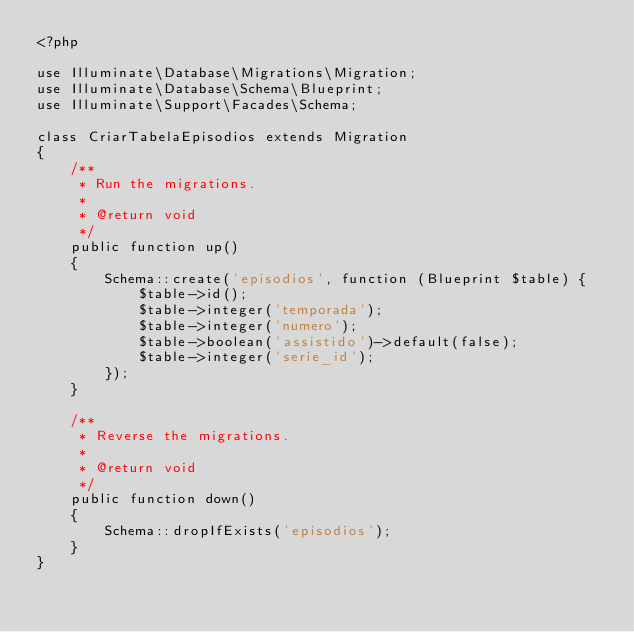Convert code to text. <code><loc_0><loc_0><loc_500><loc_500><_PHP_><?php

use Illuminate\Database\Migrations\Migration;
use Illuminate\Database\Schema\Blueprint;
use Illuminate\Support\Facades\Schema;

class CriarTabelaEpisodios extends Migration
{
    /**
     * Run the migrations.
     *
     * @return void
     */
    public function up()
    {
        Schema::create('episodios', function (Blueprint $table) {
            $table->id();
            $table->integer('temporada');
            $table->integer('numero');
            $table->boolean('assistido')->default(false);
            $table->integer('serie_id');
        });
    }

    /**
     * Reverse the migrations.
     *
     * @return void
     */
    public function down()
    {
        Schema::dropIfExists('episodios');
    }
}
</code> 